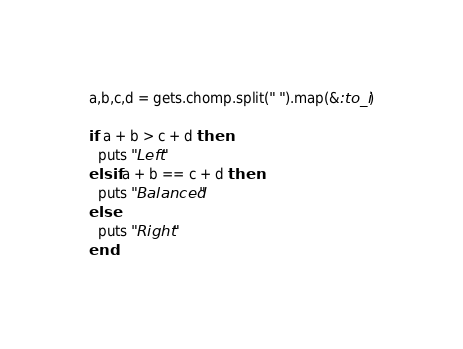Convert code to text. <code><loc_0><loc_0><loc_500><loc_500><_Ruby_>a,b,c,d = gets.chomp.split(" ").map(&:to_i)

if a + b > c + d then
  puts "Left"
elsif a + b == c + d then
  puts "Balanced"
else
  puts "Right"
end


</code> 